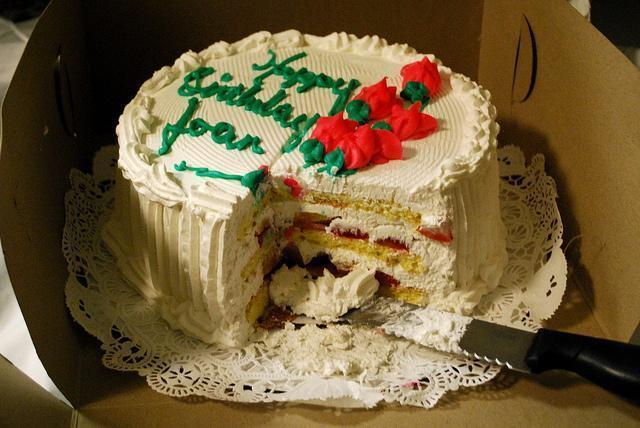How many layers is the cake made of?
Give a very brief answer. 3. How many people are wearing skis in this image?
Give a very brief answer. 0. 